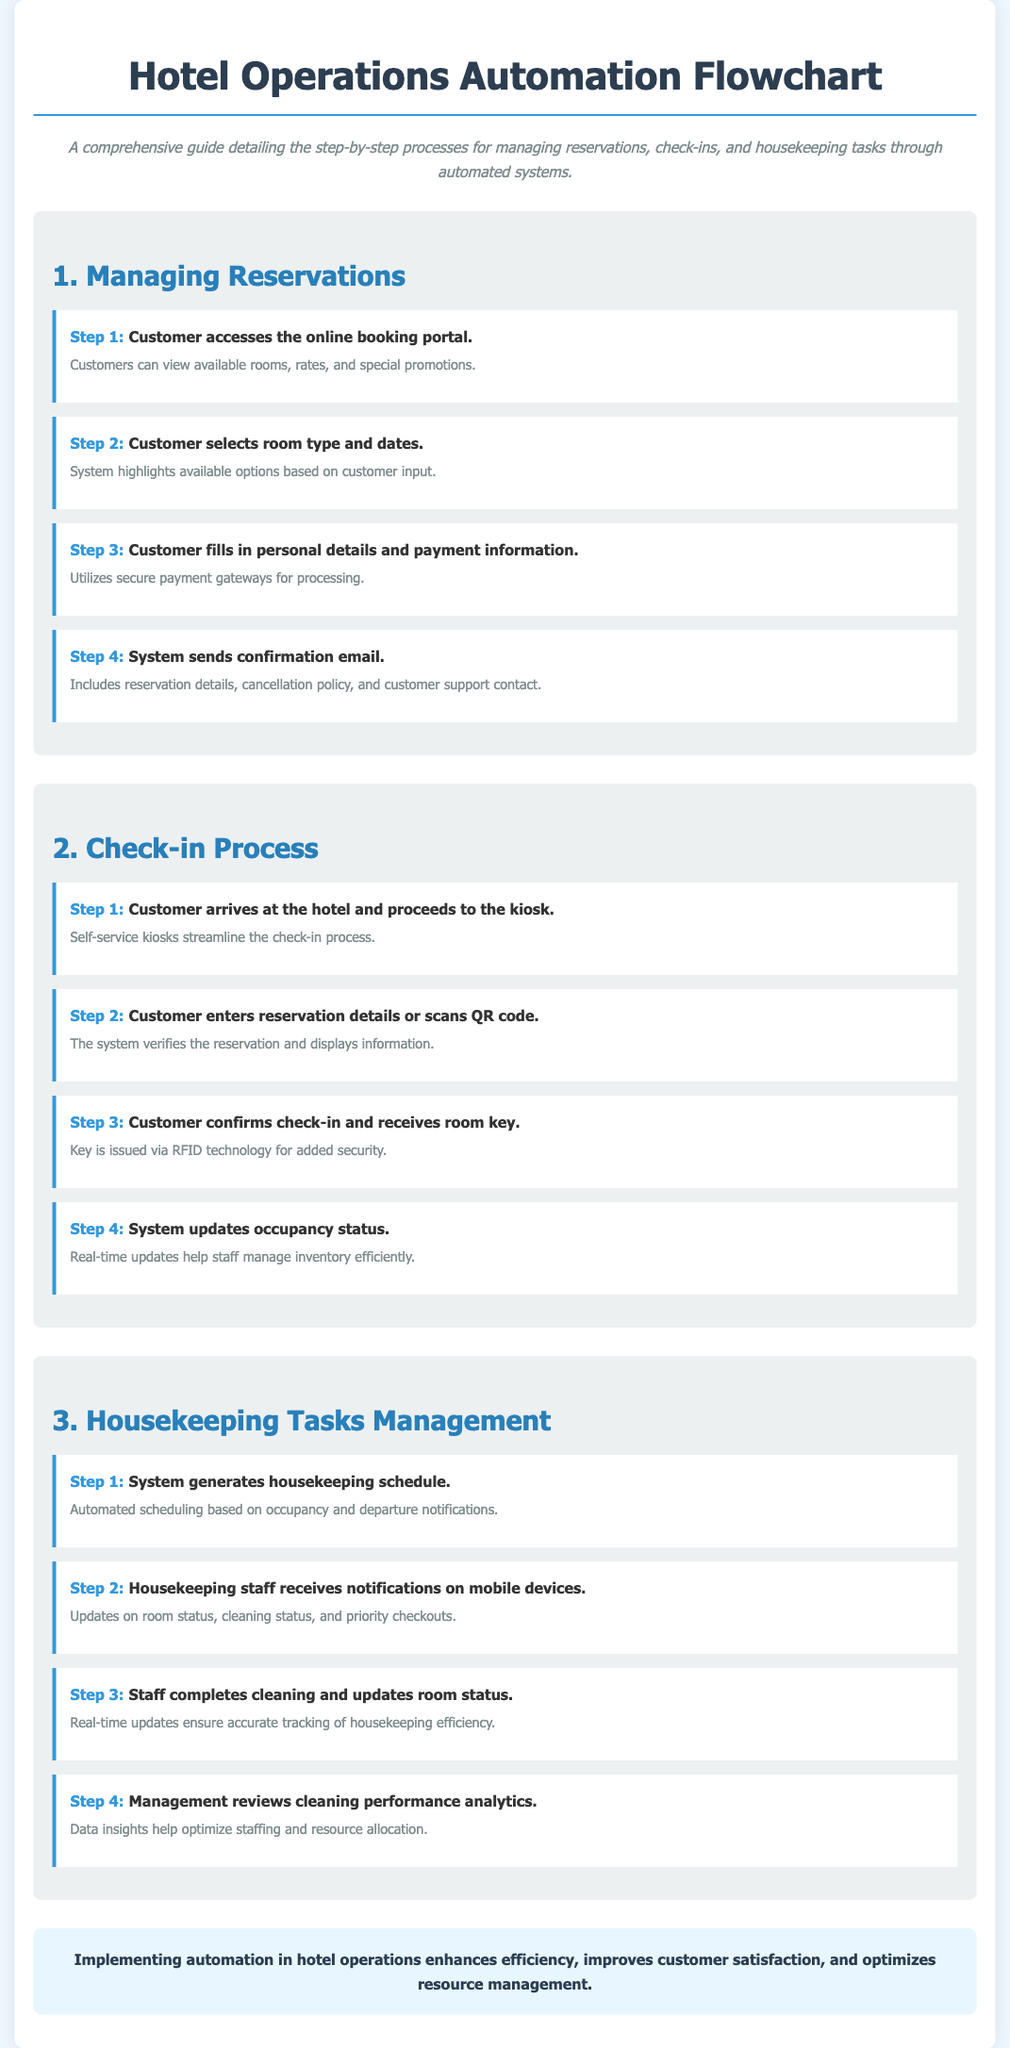What is the title of the document? The title is mentioned at the top of the document and describes the content, focusing on hotel operations automation.
Answer: Hotel Operations Automation Flowchart How many steps are there in managing reservations? The document lists the steps required in the 'Managing Reservations' section, which are outlined in a specific order.
Answer: 4 What technology is used for issuing the room key? The document describes a specific technology used during the check-in process for issuing room keys, emphasizing security.
Answer: RFID What does the system do after the customer checks in? The document states what the system updates regarding room occupancy following the check-in process.
Answer: Occupancy status What generates the housekeeping schedule? The document specifies the source of the housekeeping schedule generation based on occupancy and other notifications.
Answer: System What is included in the confirmation email? The document details what is provided in the confirmation email sent to customers after making a reservation.
Answer: Reservation details What type of devices do housekeeping staff receive notifications on? The document mentions the devices used by housekeeping staff to receive updates about their tasks and room status.
Answer: Mobile devices What is the main benefit of implementing automation in hotel operations? The document concludes with a summary of the primary advantage of incorporating automation into hotel management processes.
Answer: Efficiency 